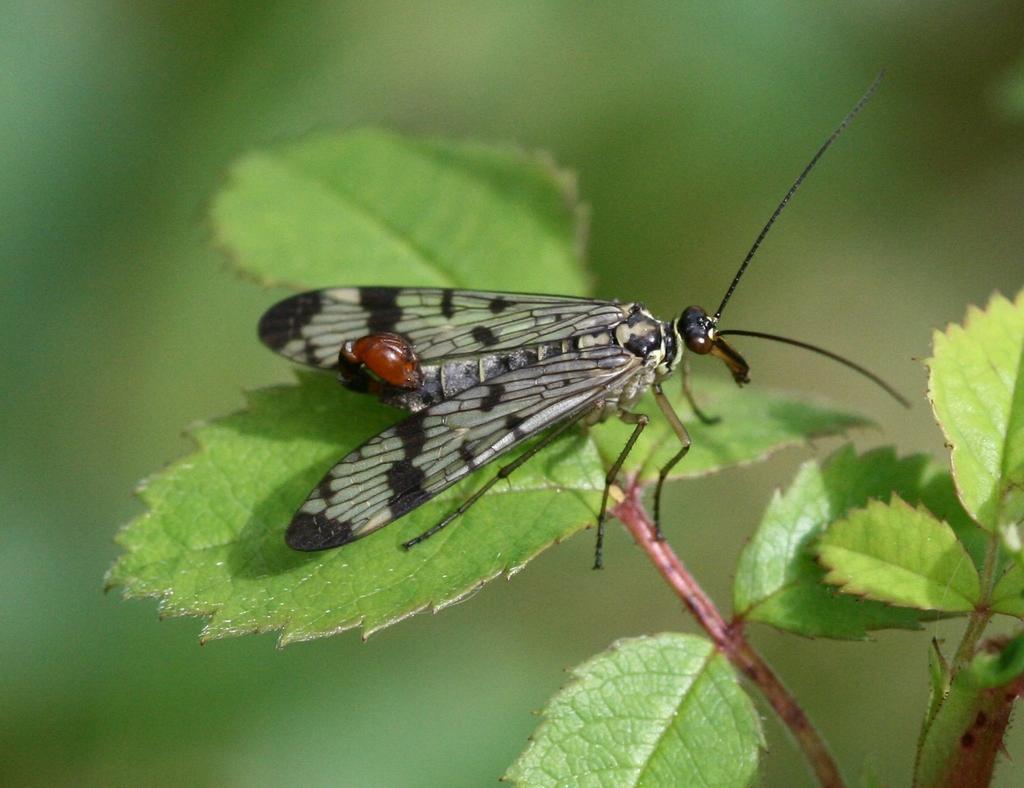Could you give a brief overview of what you see in this image? In this image we can see a insect on the leaf. The background of the image is blur. 